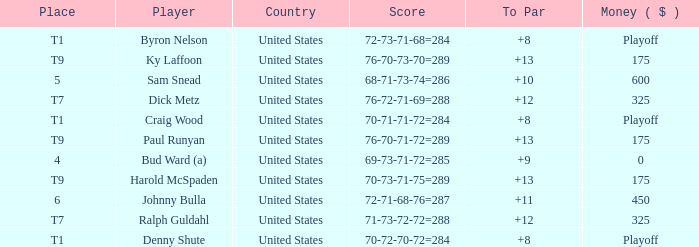Can you give me this table as a dict? {'header': ['Place', 'Player', 'Country', 'Score', 'To Par', 'Money ( $ )'], 'rows': [['T1', 'Byron Nelson', 'United States', '72-73-71-68=284', '+8', 'Playoff'], ['T9', 'Ky Laffoon', 'United States', '76-70-73-70=289', '+13', '175'], ['5', 'Sam Snead', 'United States', '68-71-73-74=286', '+10', '600'], ['T7', 'Dick Metz', 'United States', '76-72-71-69=288', '+12', '325'], ['T1', 'Craig Wood', 'United States', '70-71-71-72=284', '+8', 'Playoff'], ['T9', 'Paul Runyan', 'United States', '76-70-71-72=289', '+13', '175'], ['4', 'Bud Ward (a)', 'United States', '69-73-71-72=285', '+9', '0'], ['T9', 'Harold McSpaden', 'United States', '70-73-71-75=289', '+13', '175'], ['6', 'Johnny Bulla', 'United States', '72-71-68-76=287', '+11', '450'], ['T7', 'Ralph Guldahl', 'United States', '71-73-72-72=288', '+12', '325'], ['T1', 'Denny Shute', 'United States', '70-72-70-72=284', '+8', 'Playoff']]} Sam snead was associated with which country? United States. 